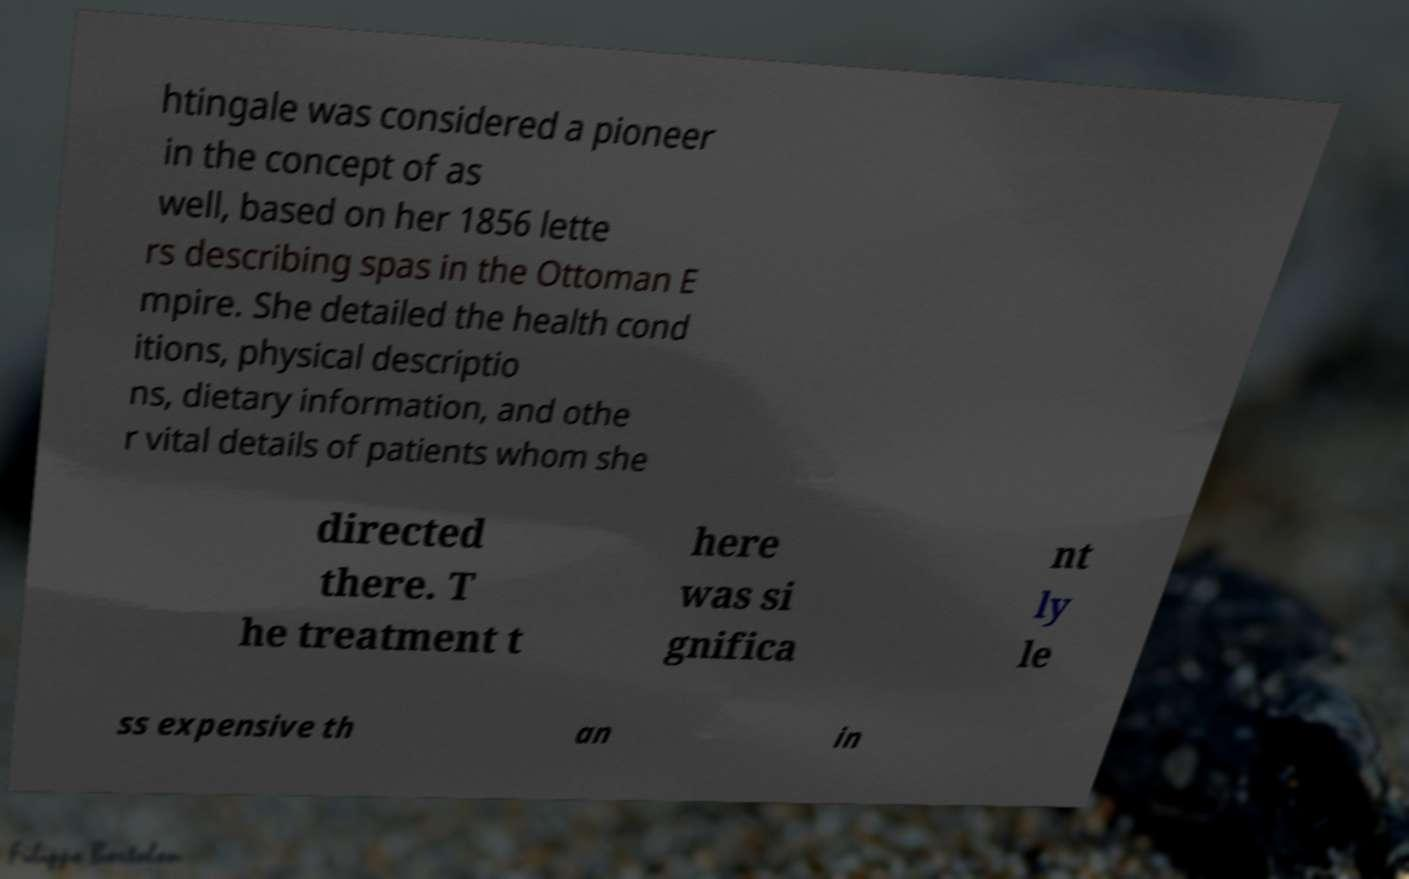Please identify and transcribe the text found in this image. htingale was considered a pioneer in the concept of as well, based on her 1856 lette rs describing spas in the Ottoman E mpire. She detailed the health cond itions, physical descriptio ns, dietary information, and othe r vital details of patients whom she directed there. T he treatment t here was si gnifica nt ly le ss expensive th an in 